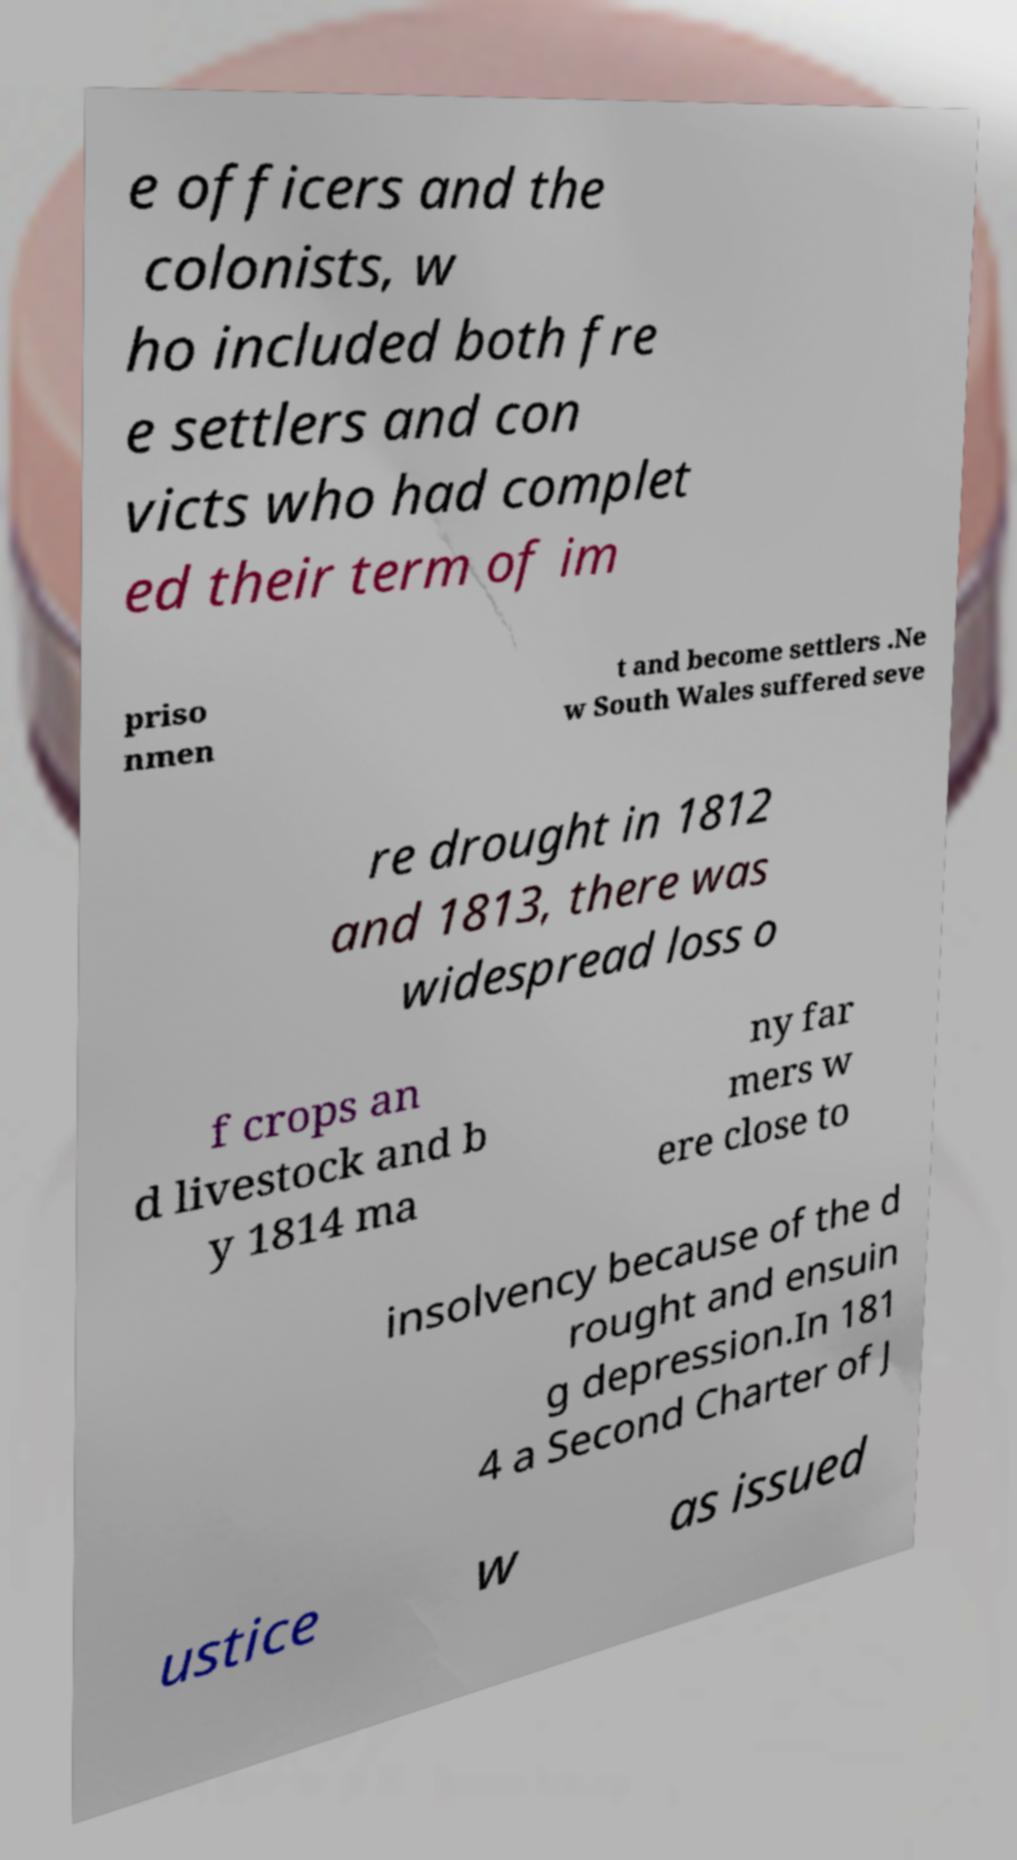There's text embedded in this image that I need extracted. Can you transcribe it verbatim? e officers and the colonists, w ho included both fre e settlers and con victs who had complet ed their term of im priso nmen t and become settlers .Ne w South Wales suffered seve re drought in 1812 and 1813, there was widespread loss o f crops an d livestock and b y 1814 ma ny far mers w ere close to insolvency because of the d rought and ensuin g depression.In 181 4 a Second Charter of J ustice w as issued 